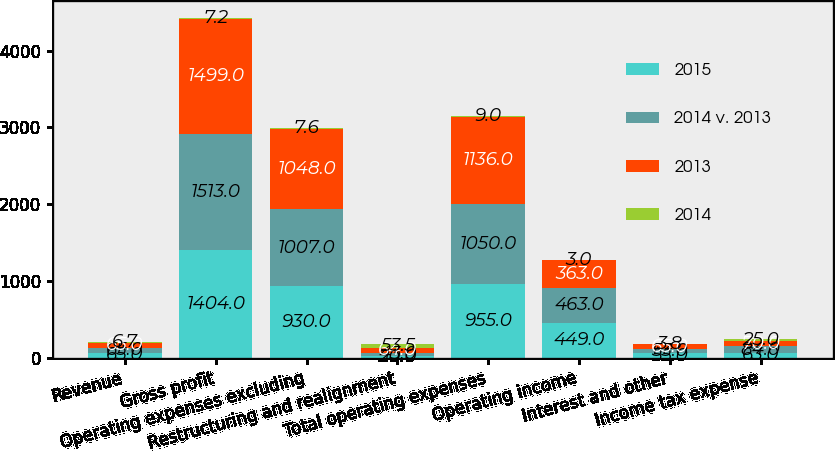<chart> <loc_0><loc_0><loc_500><loc_500><stacked_bar_chart><ecel><fcel>Revenue<fcel>Gross profit<fcel>Operating expenses excluding<fcel>Restructuring and realignment<fcel>Total operating expenses<fcel>Operating income<fcel>Interest and other<fcel>Income tax expense<nl><fcel>2015<fcel>65<fcel>1404<fcel>930<fcel>20<fcel>955<fcel>449<fcel>55<fcel>63<nl><fcel>2014 v. 2013<fcel>65<fcel>1513<fcel>1007<fcel>43<fcel>1050<fcel>463<fcel>53<fcel>84<nl><fcel>2013<fcel>65<fcel>1499<fcel>1048<fcel>64<fcel>1136<fcel>363<fcel>65<fcel>70<nl><fcel>2014<fcel>6.7<fcel>7.2<fcel>7.6<fcel>53.5<fcel>9<fcel>3<fcel>3.8<fcel>25<nl></chart> 